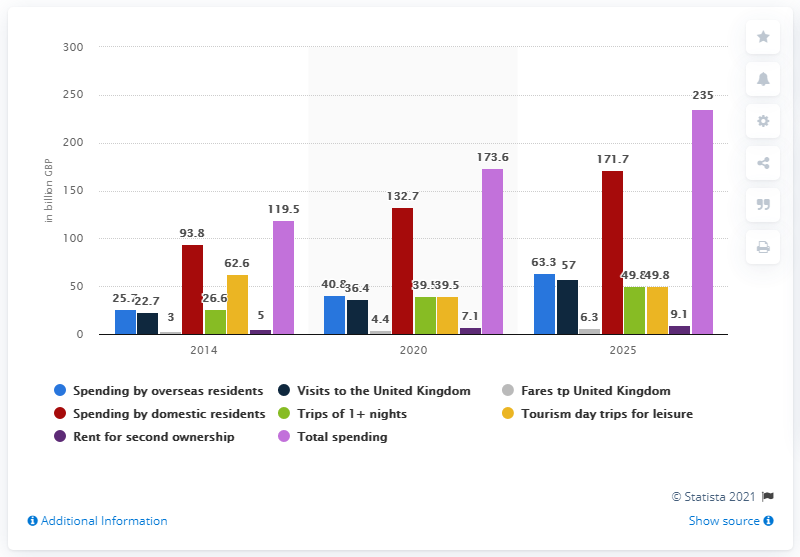What is the estimated spending by domestic residents in the UK by 2020? The estimated spending by domestic residents in the UK for the year 2020 amounted to 132.7 billion GBP as seen in the bar chart. This represents a significant increase from previous years, reflecting dynamic economic activities despite various challenges. 